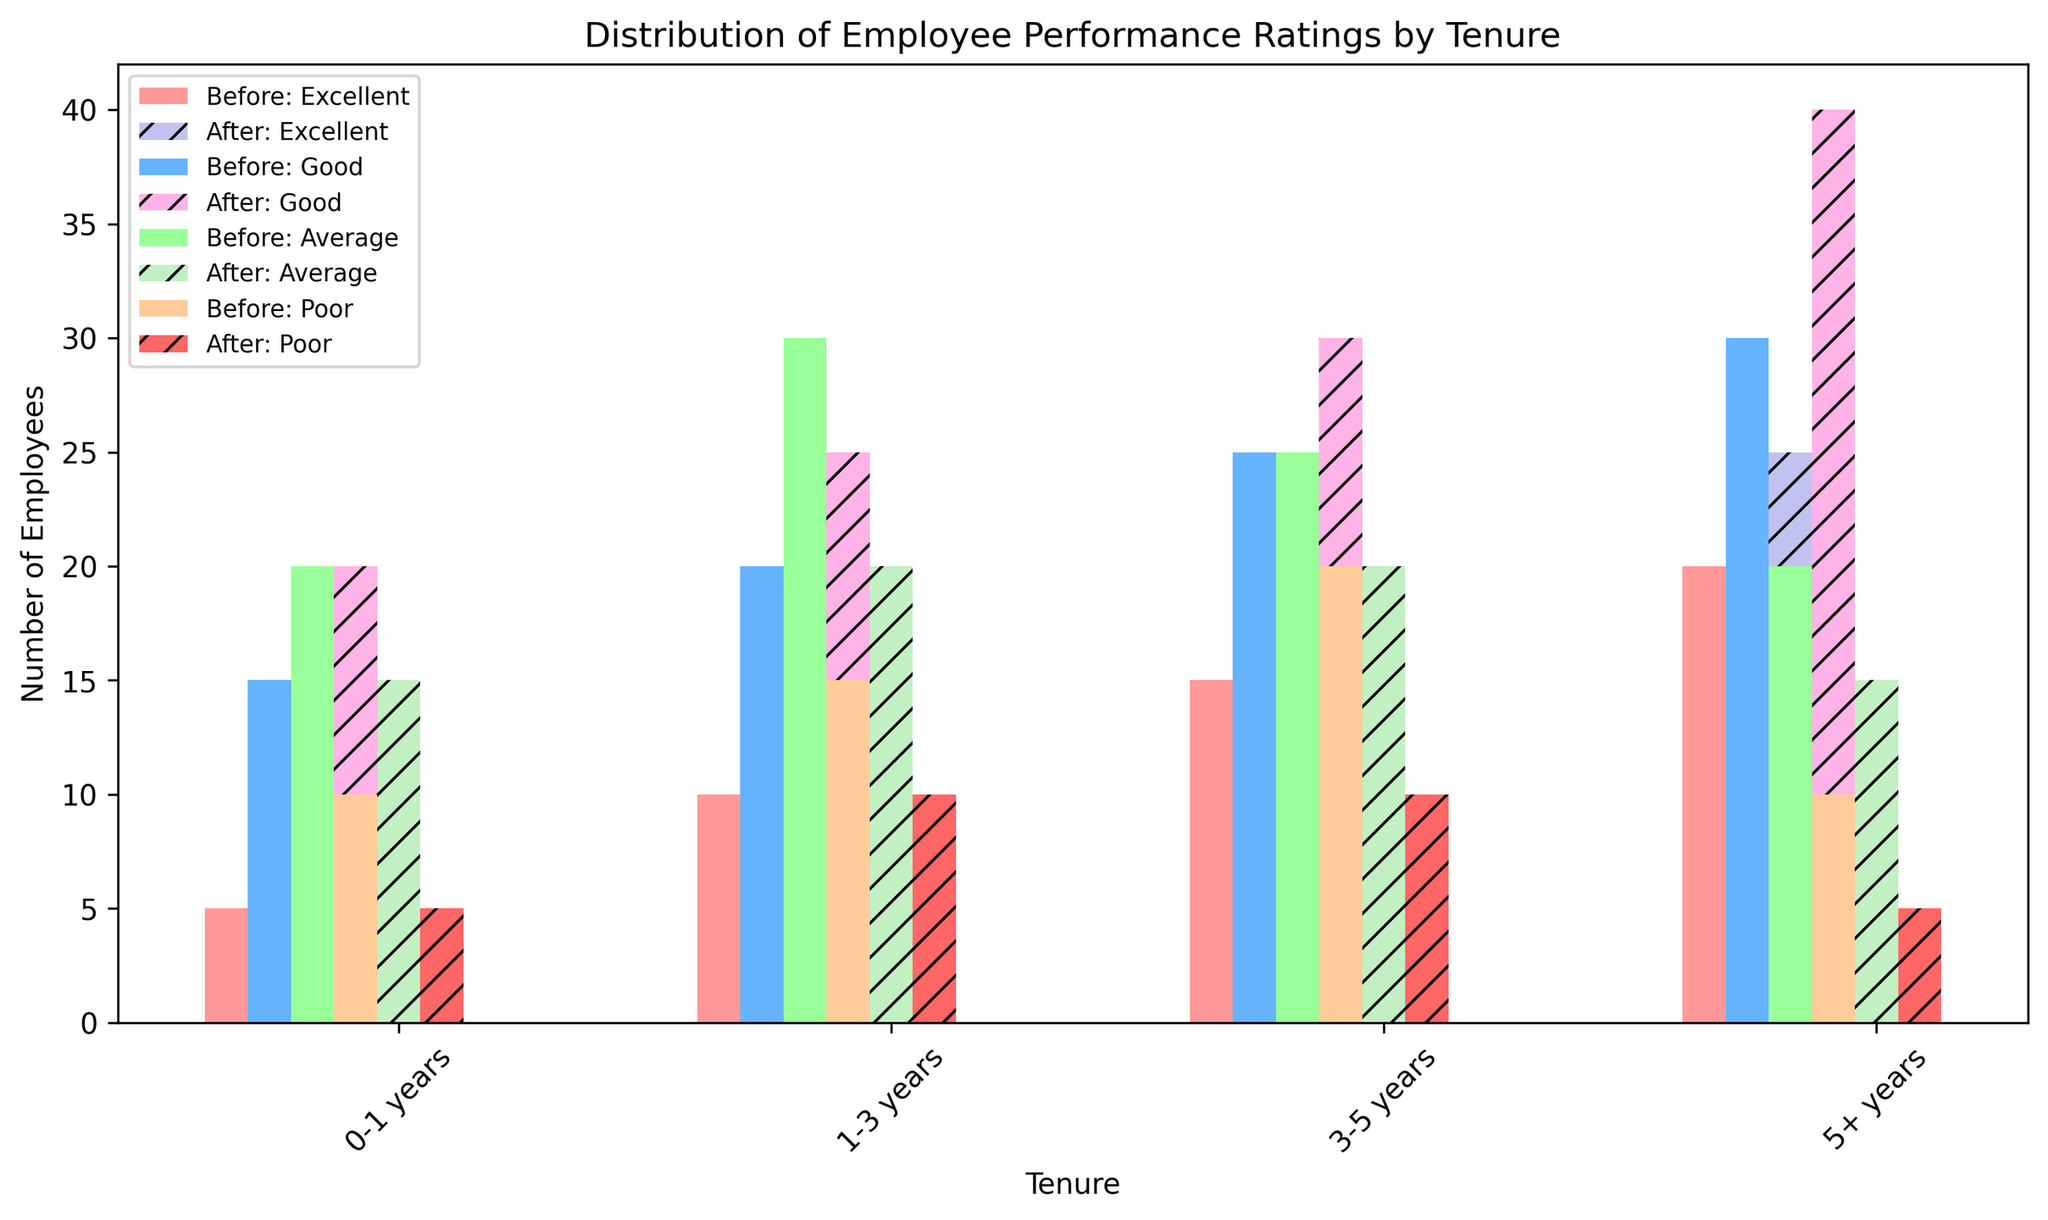Which tenure group saw the highest increase in the number of employees rated as Excellent after the training program? Look at the Excellent rating category for each tenure group. Compare the Before and After bars. The 0-1 years group increased from 5 to 10, the 1-3 years group from 10 to 15, the 3-5 years group from 15 to 20, and the 5+ years group from 20 to 25. The increase for each group is 5, indicating all groups saw the same increase.
Answer: 0-1 years, 1-3 years, 3-5 years, 5+ years Which performance rating saw the biggest decline after training in the 1-3 years tenure group? Look at the 1-3 years tenure group and compare bars for each performance rating. The Average rating decreased from 30 to 20, a drop of 10, which is the largest decline.
Answer: Average What are the total numbers of employees rated as Good before and after training in the 3-5 years tenure group? Sum the values of the Good rating for the 3-5 years group. Before training is 25, and after training is 30. The totals are 25 and 30, respectively.
Answer: 25, 30 Which performance rating for the 0-1 years tenure group has the smallest difference between before and after training? Calculate the difference between Before and After training for each rating. Excellent went from 5 to 10 (difference 5), Good from 15 to 20 (difference 5), Average from 20 to 15 (difference 5), and Poor from 10 to 5 (difference 5). All differences are equal.
Answer: All ratings Are there more employees with Poor ratings after training or before training in the 5+ years tenure group? Compare the Poor rating bars for the 5+ years group. Before training shows 10 employees and after training shows 5. There are more before training.
Answer: Before training Which tenure group had the largest total number of employees rated as Excellent after training? Sum the values of the Excellent rating in each tenure group after training. 0-1 years have 10, 1-3 years have 15, 3-5 years have 20, and 5+ years have 25. The 5+ years group has the largest total.
Answer: 5+ years In which tenure group did the number of employees with an Average rating decrease the most after training? Compare the Average rating values before and after training for each tenure group. 0-1 years decreased from 20 to 15 (5), 1-3 years from 30 to 20 (10), 3-5 years from 25 to 20 (5), and 5+ years from 20 to 15 (5). The largest decrease is in the 1-3 years group.
Answer: 1-3 years What is the combined total number of employees rated as Excellent and Poor before training in the 3-5 years tenure group? Add the numbers of Excellent and Poor ratings before training in the 3-5 years group. Excellent is 15, and Poor is 20. Thus, the combined total is 15 + 20.
Answer: 35 Which performance rating had the largest increase across all tenure groups after the training? Calculate the change for each rating across all tenure groups. Add the differences for Excellent from all tenure groups (5+5+5+5=20), and repeat for Good (5+5+5+10=25), Average (-5-10-5-5=-25), and Poor (-5-5-10-5=-25). The largest increase is for the Good rating.
Answer: Good 